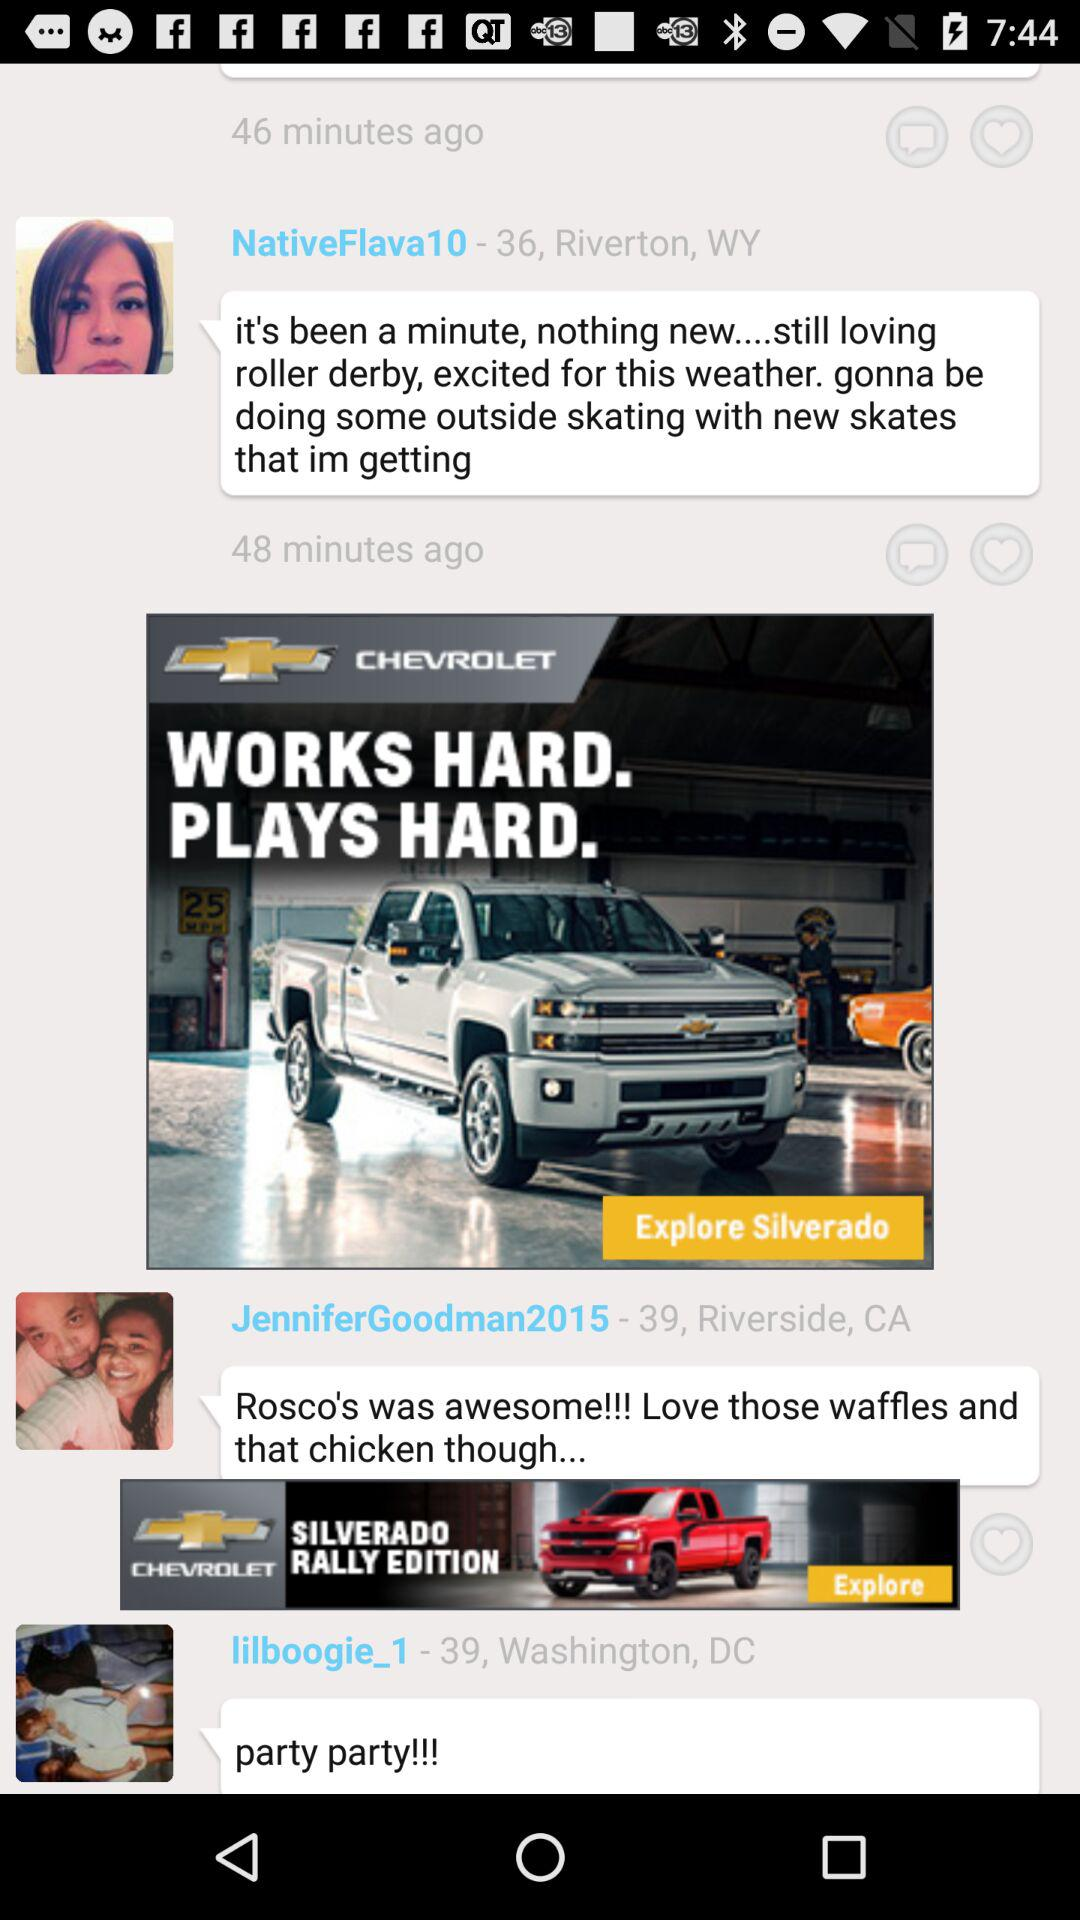What is the location of "lilboogie_1"? The location is 39, Washington, DC. 